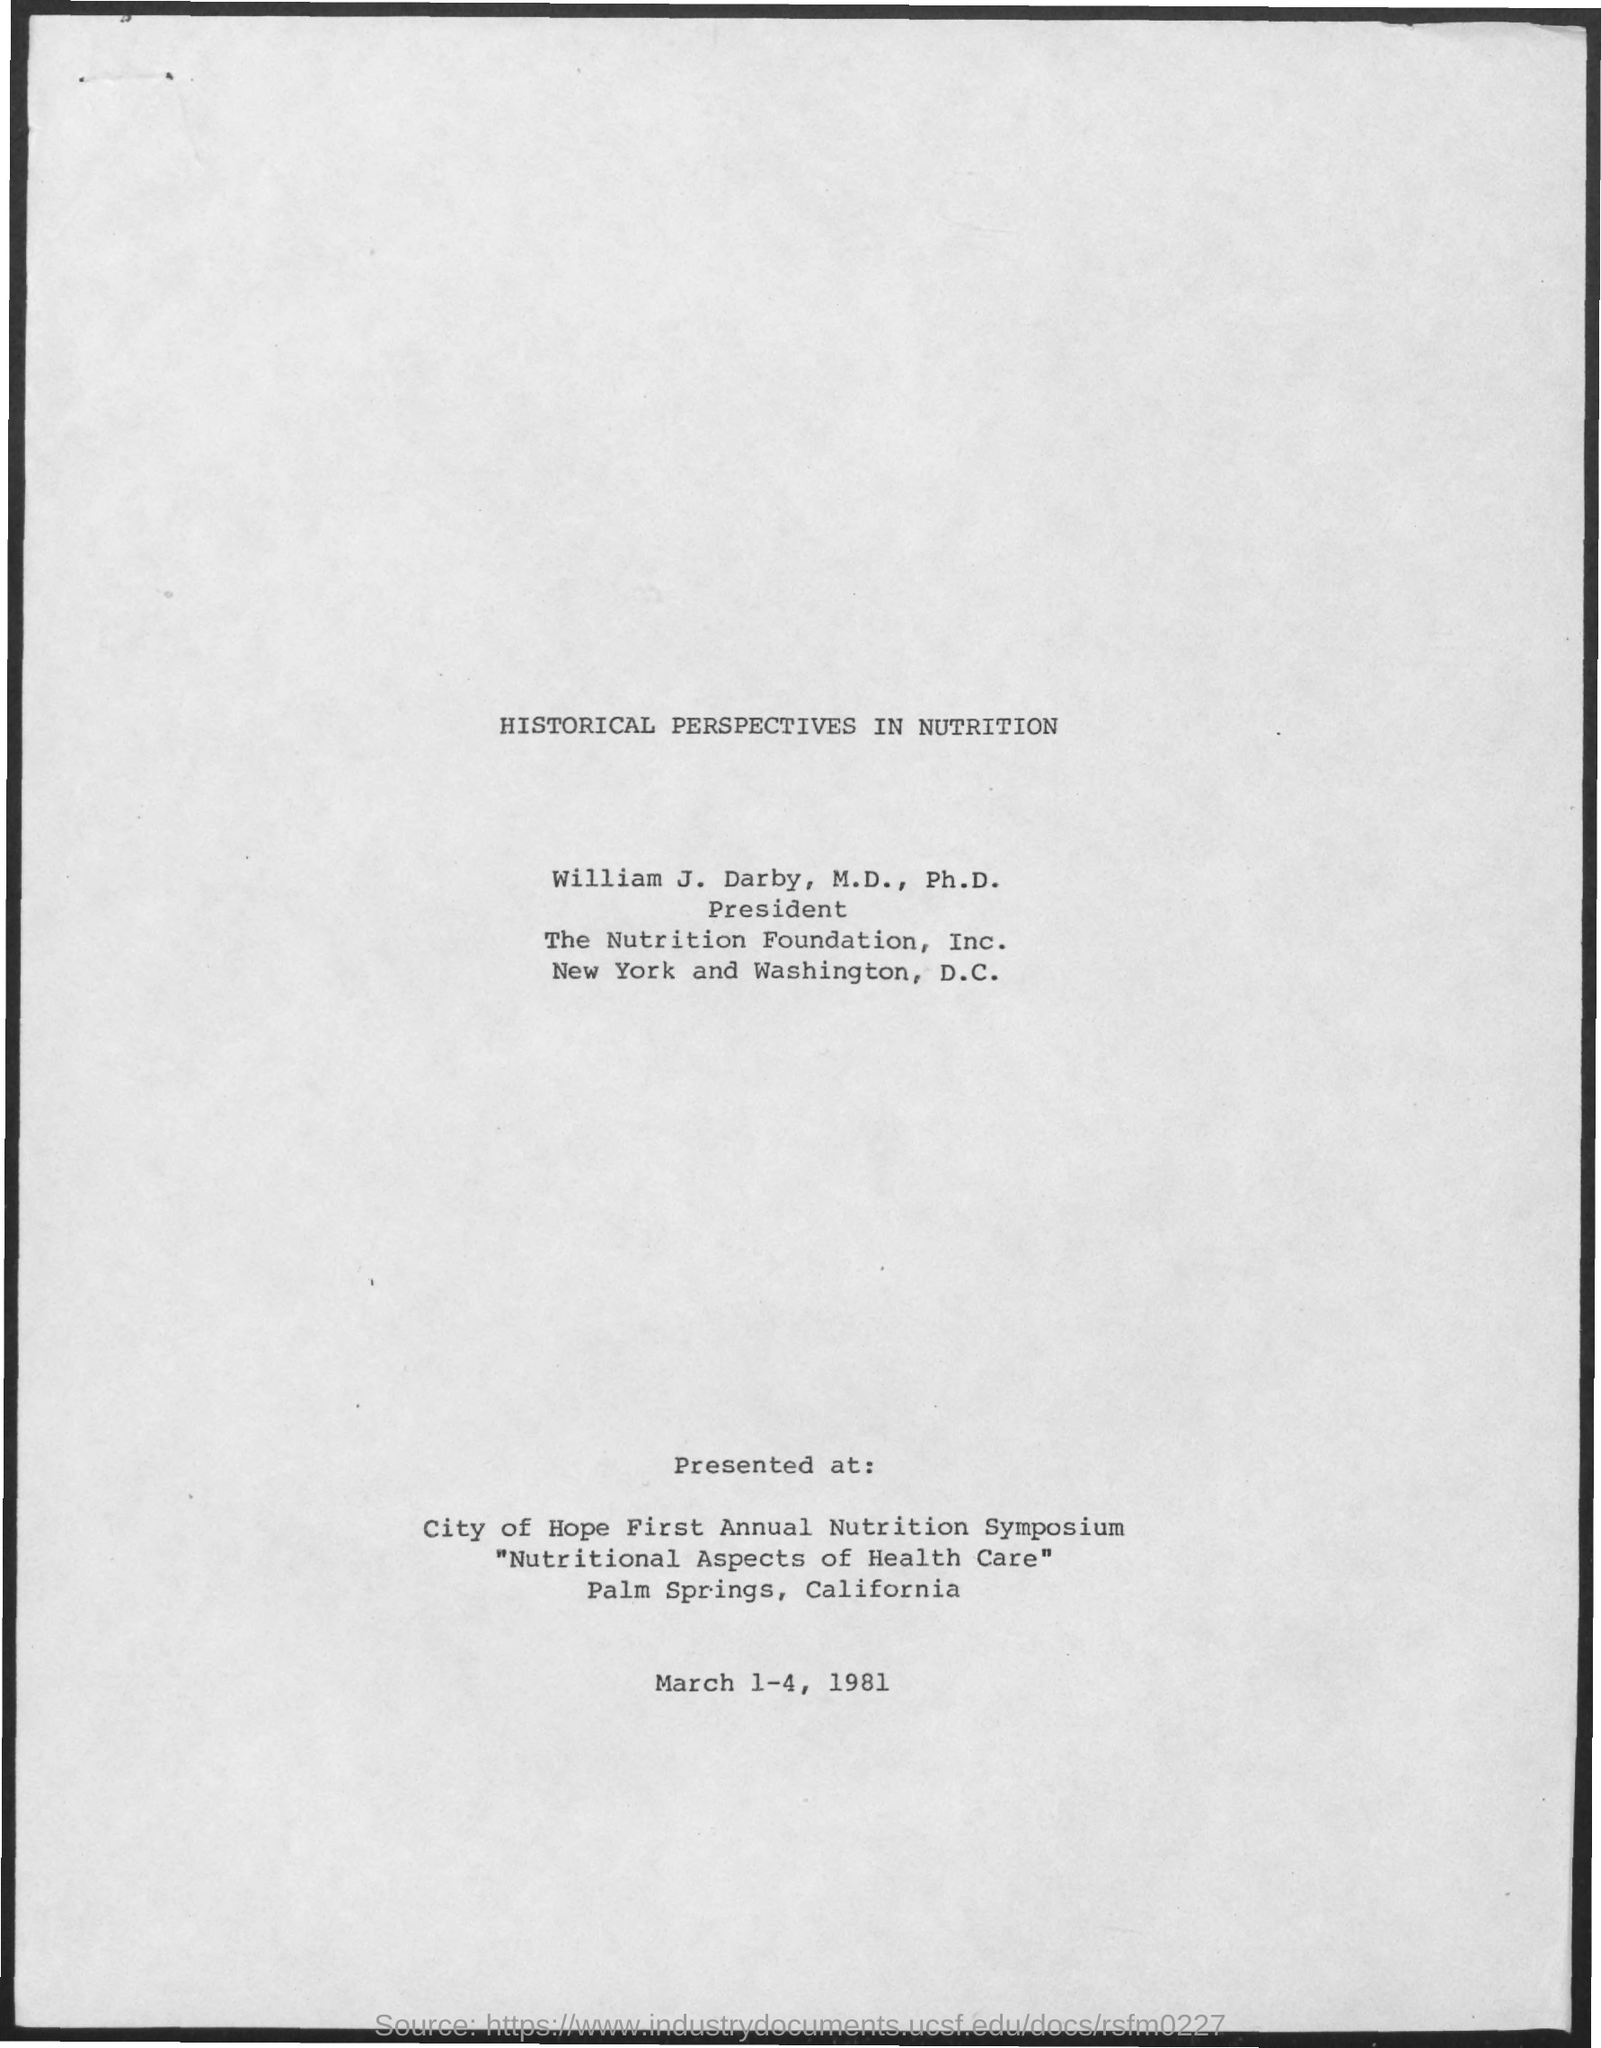Indicate a few pertinent items in this graphic. The presentation took place from March 1st to March 4th, 1981. The presentation took place at the City of Hope First Annual Nutrition Symposium. This document provides historical perspectives on nutrition and its significance in human health and wellbeing. 